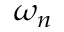Convert formula to latex. <formula><loc_0><loc_0><loc_500><loc_500>\omega _ { n }</formula> 